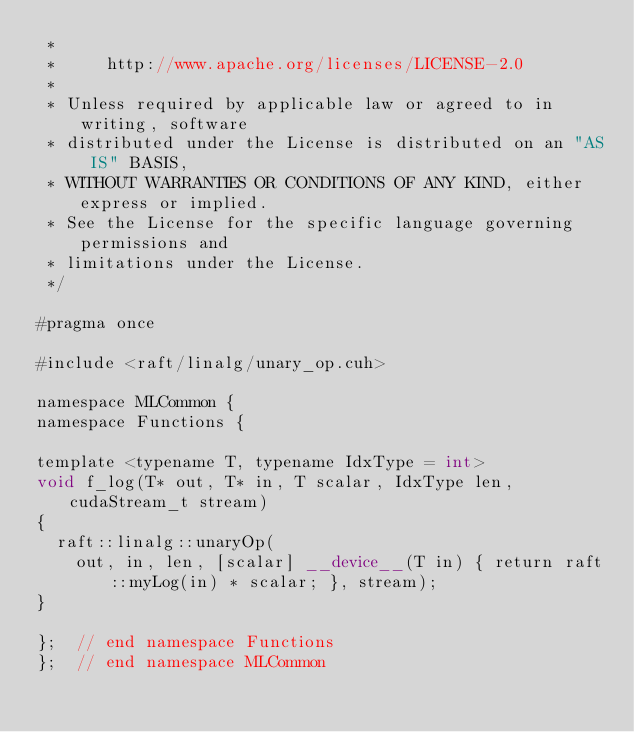Convert code to text. <code><loc_0><loc_0><loc_500><loc_500><_Cuda_> *
 *     http://www.apache.org/licenses/LICENSE-2.0
 *
 * Unless required by applicable law or agreed to in writing, software
 * distributed under the License is distributed on an "AS IS" BASIS,
 * WITHOUT WARRANTIES OR CONDITIONS OF ANY KIND, either express or implied.
 * See the License for the specific language governing permissions and
 * limitations under the License.
 */

#pragma once

#include <raft/linalg/unary_op.cuh>

namespace MLCommon {
namespace Functions {

template <typename T, typename IdxType = int>
void f_log(T* out, T* in, T scalar, IdxType len, cudaStream_t stream)
{
  raft::linalg::unaryOp(
    out, in, len, [scalar] __device__(T in) { return raft::myLog(in) * scalar; }, stream);
}

};  // end namespace Functions
};  // end namespace MLCommon
</code> 